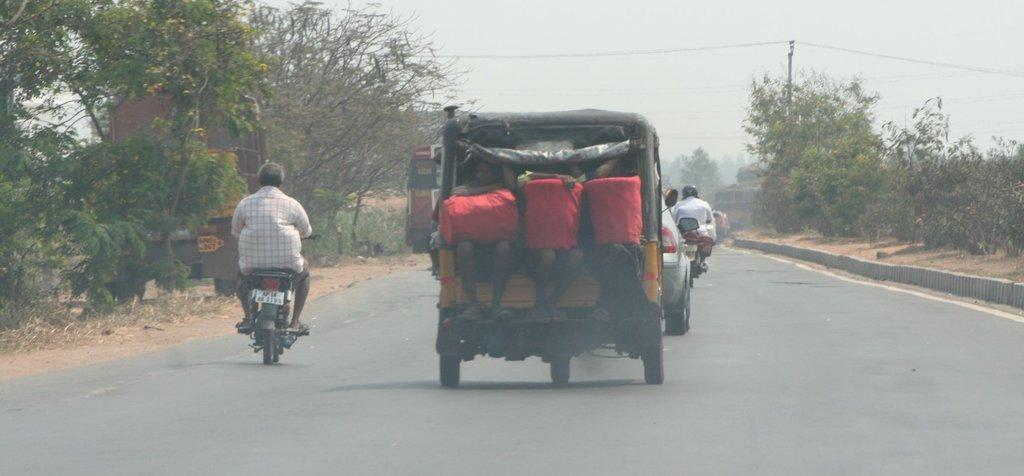What can be seen on the road in the image? There are vehicles on the road in the image. What are the people in the image wearing? The people in the image are wearing clothes. What type of vegetation is present in the image? There are trees and grass in the image. What else can be seen in the image besides the vehicles and people? There are electric wires in the image. What is visible at the top of the image? The sky is visible in the image. What type of bun is being used to point at the joke in the image? There is no bun, pointing, or joke present in the image. What type of joke is being told by the people in the image? There is no joke being told in the image; the people are simply wearing clothes and interacting with their surroundings. 